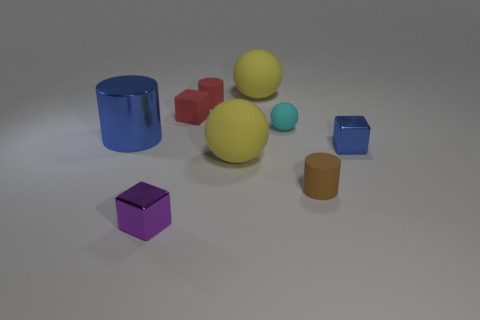Are there any other things of the same color as the tiny rubber block? Yes, there is at least one larger block that shares the same vibrant purple hue as the tiny rubber block. 